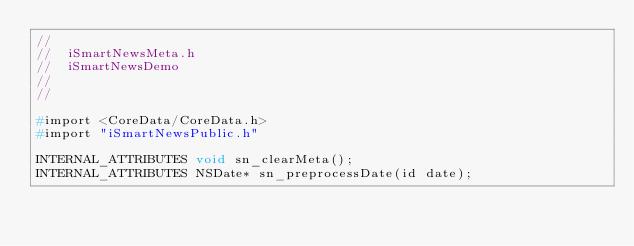<code> <loc_0><loc_0><loc_500><loc_500><_C_>//
//  iSmartNewsMeta.h
//  iSmartNewsDemo
//
//

#import <CoreData/CoreData.h>
#import "iSmartNewsPublic.h"

INTERNAL_ATTRIBUTES void sn_clearMeta();
INTERNAL_ATTRIBUTES NSDate* sn_preprocessDate(id date);
</code> 